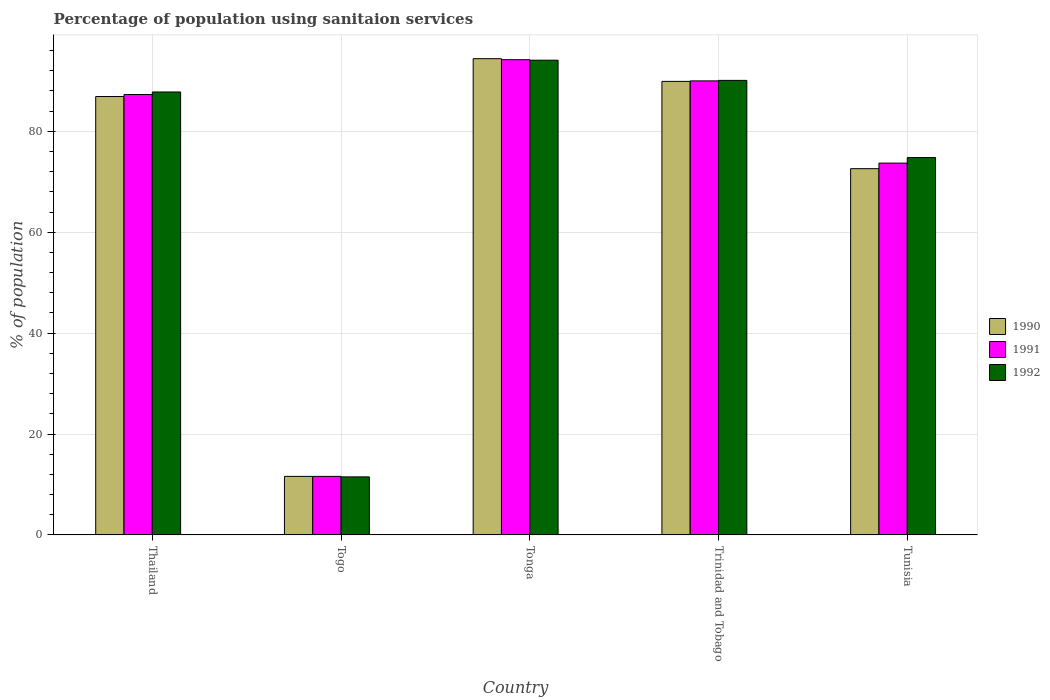How many different coloured bars are there?
Your response must be concise. 3. Are the number of bars on each tick of the X-axis equal?
Keep it short and to the point. Yes. How many bars are there on the 3rd tick from the left?
Offer a terse response. 3. What is the label of the 5th group of bars from the left?
Provide a short and direct response. Tunisia. In how many cases, is the number of bars for a given country not equal to the number of legend labels?
Offer a terse response. 0. What is the percentage of population using sanitaion services in 1992 in Thailand?
Give a very brief answer. 87.8. Across all countries, what is the maximum percentage of population using sanitaion services in 1992?
Keep it short and to the point. 94.1. In which country was the percentage of population using sanitaion services in 1991 maximum?
Offer a terse response. Tonga. In which country was the percentage of population using sanitaion services in 1992 minimum?
Offer a very short reply. Togo. What is the total percentage of population using sanitaion services in 1990 in the graph?
Keep it short and to the point. 355.4. What is the difference between the percentage of population using sanitaion services in 1990 in Togo and that in Trinidad and Tobago?
Provide a short and direct response. -78.3. What is the difference between the percentage of population using sanitaion services in 1992 in Tonga and the percentage of population using sanitaion services in 1990 in Trinidad and Tobago?
Your answer should be compact. 4.2. What is the average percentage of population using sanitaion services in 1991 per country?
Give a very brief answer. 71.36. What is the difference between the percentage of population using sanitaion services of/in 1990 and percentage of population using sanitaion services of/in 1991 in Tonga?
Your answer should be compact. 0.2. In how many countries, is the percentage of population using sanitaion services in 1990 greater than 24 %?
Your response must be concise. 4. What is the ratio of the percentage of population using sanitaion services in 1990 in Thailand to that in Trinidad and Tobago?
Offer a terse response. 0.97. Is the difference between the percentage of population using sanitaion services in 1990 in Thailand and Togo greater than the difference between the percentage of population using sanitaion services in 1991 in Thailand and Togo?
Your response must be concise. No. What is the difference between the highest and the lowest percentage of population using sanitaion services in 1992?
Make the answer very short. 82.6. In how many countries, is the percentage of population using sanitaion services in 1991 greater than the average percentage of population using sanitaion services in 1991 taken over all countries?
Offer a terse response. 4. What does the 1st bar from the left in Togo represents?
Make the answer very short. 1990. Is it the case that in every country, the sum of the percentage of population using sanitaion services in 1992 and percentage of population using sanitaion services in 1990 is greater than the percentage of population using sanitaion services in 1991?
Your answer should be very brief. Yes. How many countries are there in the graph?
Give a very brief answer. 5. What is the difference between two consecutive major ticks on the Y-axis?
Your response must be concise. 20. Does the graph contain any zero values?
Your answer should be compact. No. Where does the legend appear in the graph?
Provide a succinct answer. Center right. How many legend labels are there?
Provide a short and direct response. 3. How are the legend labels stacked?
Your response must be concise. Vertical. What is the title of the graph?
Give a very brief answer. Percentage of population using sanitaion services. What is the label or title of the X-axis?
Provide a short and direct response. Country. What is the label or title of the Y-axis?
Offer a terse response. % of population. What is the % of population of 1990 in Thailand?
Give a very brief answer. 86.9. What is the % of population of 1991 in Thailand?
Ensure brevity in your answer.  87.3. What is the % of population of 1992 in Thailand?
Your answer should be very brief. 87.8. What is the % of population in 1990 in Togo?
Make the answer very short. 11.6. What is the % of population in 1990 in Tonga?
Your response must be concise. 94.4. What is the % of population of 1991 in Tonga?
Keep it short and to the point. 94.2. What is the % of population of 1992 in Tonga?
Your answer should be very brief. 94.1. What is the % of population in 1990 in Trinidad and Tobago?
Keep it short and to the point. 89.9. What is the % of population of 1992 in Trinidad and Tobago?
Offer a terse response. 90.1. What is the % of population of 1990 in Tunisia?
Your answer should be very brief. 72.6. What is the % of population in 1991 in Tunisia?
Provide a succinct answer. 73.7. What is the % of population of 1992 in Tunisia?
Your answer should be very brief. 74.8. Across all countries, what is the maximum % of population in 1990?
Make the answer very short. 94.4. Across all countries, what is the maximum % of population in 1991?
Give a very brief answer. 94.2. Across all countries, what is the maximum % of population of 1992?
Provide a succinct answer. 94.1. Across all countries, what is the minimum % of population in 1990?
Your answer should be compact. 11.6. What is the total % of population in 1990 in the graph?
Ensure brevity in your answer.  355.4. What is the total % of population of 1991 in the graph?
Keep it short and to the point. 356.8. What is the total % of population in 1992 in the graph?
Your answer should be very brief. 358.3. What is the difference between the % of population of 1990 in Thailand and that in Togo?
Provide a short and direct response. 75.3. What is the difference between the % of population in 1991 in Thailand and that in Togo?
Make the answer very short. 75.7. What is the difference between the % of population in 1992 in Thailand and that in Togo?
Provide a succinct answer. 76.3. What is the difference between the % of population in 1991 in Thailand and that in Tonga?
Give a very brief answer. -6.9. What is the difference between the % of population of 1990 in Thailand and that in Trinidad and Tobago?
Provide a short and direct response. -3. What is the difference between the % of population of 1992 in Thailand and that in Trinidad and Tobago?
Provide a short and direct response. -2.3. What is the difference between the % of population in 1991 in Thailand and that in Tunisia?
Ensure brevity in your answer.  13.6. What is the difference between the % of population in 1992 in Thailand and that in Tunisia?
Offer a very short reply. 13. What is the difference between the % of population of 1990 in Togo and that in Tonga?
Keep it short and to the point. -82.8. What is the difference between the % of population in 1991 in Togo and that in Tonga?
Offer a very short reply. -82.6. What is the difference between the % of population in 1992 in Togo and that in Tonga?
Your answer should be compact. -82.6. What is the difference between the % of population in 1990 in Togo and that in Trinidad and Tobago?
Ensure brevity in your answer.  -78.3. What is the difference between the % of population of 1991 in Togo and that in Trinidad and Tobago?
Your answer should be very brief. -78.4. What is the difference between the % of population of 1992 in Togo and that in Trinidad and Tobago?
Ensure brevity in your answer.  -78.6. What is the difference between the % of population in 1990 in Togo and that in Tunisia?
Make the answer very short. -61. What is the difference between the % of population in 1991 in Togo and that in Tunisia?
Make the answer very short. -62.1. What is the difference between the % of population in 1992 in Togo and that in Tunisia?
Provide a succinct answer. -63.3. What is the difference between the % of population of 1990 in Tonga and that in Trinidad and Tobago?
Provide a short and direct response. 4.5. What is the difference between the % of population in 1992 in Tonga and that in Trinidad and Tobago?
Give a very brief answer. 4. What is the difference between the % of population of 1990 in Tonga and that in Tunisia?
Your answer should be compact. 21.8. What is the difference between the % of population of 1992 in Tonga and that in Tunisia?
Your response must be concise. 19.3. What is the difference between the % of population in 1990 in Trinidad and Tobago and that in Tunisia?
Your answer should be very brief. 17.3. What is the difference between the % of population in 1990 in Thailand and the % of population in 1991 in Togo?
Keep it short and to the point. 75.3. What is the difference between the % of population in 1990 in Thailand and the % of population in 1992 in Togo?
Provide a short and direct response. 75.4. What is the difference between the % of population of 1991 in Thailand and the % of population of 1992 in Togo?
Offer a terse response. 75.8. What is the difference between the % of population of 1990 in Thailand and the % of population of 1992 in Trinidad and Tobago?
Your response must be concise. -3.2. What is the difference between the % of population of 1991 in Thailand and the % of population of 1992 in Trinidad and Tobago?
Your answer should be compact. -2.8. What is the difference between the % of population of 1990 in Thailand and the % of population of 1992 in Tunisia?
Your answer should be compact. 12.1. What is the difference between the % of population in 1991 in Thailand and the % of population in 1992 in Tunisia?
Provide a succinct answer. 12.5. What is the difference between the % of population in 1990 in Togo and the % of population in 1991 in Tonga?
Provide a short and direct response. -82.6. What is the difference between the % of population of 1990 in Togo and the % of population of 1992 in Tonga?
Your response must be concise. -82.5. What is the difference between the % of population of 1991 in Togo and the % of population of 1992 in Tonga?
Your answer should be compact. -82.5. What is the difference between the % of population in 1990 in Togo and the % of population in 1991 in Trinidad and Tobago?
Give a very brief answer. -78.4. What is the difference between the % of population in 1990 in Togo and the % of population in 1992 in Trinidad and Tobago?
Provide a succinct answer. -78.5. What is the difference between the % of population in 1991 in Togo and the % of population in 1992 in Trinidad and Tobago?
Make the answer very short. -78.5. What is the difference between the % of population of 1990 in Togo and the % of population of 1991 in Tunisia?
Your response must be concise. -62.1. What is the difference between the % of population of 1990 in Togo and the % of population of 1992 in Tunisia?
Provide a succinct answer. -63.2. What is the difference between the % of population of 1991 in Togo and the % of population of 1992 in Tunisia?
Provide a succinct answer. -63.2. What is the difference between the % of population in 1990 in Tonga and the % of population in 1991 in Trinidad and Tobago?
Offer a terse response. 4.4. What is the difference between the % of population in 1990 in Tonga and the % of population in 1992 in Trinidad and Tobago?
Your answer should be very brief. 4.3. What is the difference between the % of population in 1991 in Tonga and the % of population in 1992 in Trinidad and Tobago?
Offer a very short reply. 4.1. What is the difference between the % of population of 1990 in Tonga and the % of population of 1991 in Tunisia?
Your answer should be very brief. 20.7. What is the difference between the % of population in 1990 in Tonga and the % of population in 1992 in Tunisia?
Provide a short and direct response. 19.6. What is the difference between the % of population in 1991 in Tonga and the % of population in 1992 in Tunisia?
Provide a succinct answer. 19.4. What is the average % of population of 1990 per country?
Your response must be concise. 71.08. What is the average % of population of 1991 per country?
Make the answer very short. 71.36. What is the average % of population of 1992 per country?
Offer a terse response. 71.66. What is the difference between the % of population in 1990 and % of population in 1991 in Thailand?
Keep it short and to the point. -0.4. What is the difference between the % of population of 1991 and % of population of 1992 in Thailand?
Your answer should be compact. -0.5. What is the difference between the % of population in 1990 and % of population in 1991 in Togo?
Your response must be concise. 0. What is the difference between the % of population of 1990 and % of population of 1992 in Togo?
Offer a terse response. 0.1. What is the difference between the % of population in 1990 and % of population in 1991 in Tonga?
Provide a short and direct response. 0.2. What is the difference between the % of population of 1990 and % of population of 1992 in Tonga?
Provide a short and direct response. 0.3. What is the difference between the % of population of 1991 and % of population of 1992 in Tonga?
Provide a short and direct response. 0.1. What is the difference between the % of population in 1990 and % of population in 1991 in Tunisia?
Keep it short and to the point. -1.1. What is the difference between the % of population in 1990 and % of population in 1992 in Tunisia?
Make the answer very short. -2.2. What is the difference between the % of population in 1991 and % of population in 1992 in Tunisia?
Keep it short and to the point. -1.1. What is the ratio of the % of population in 1990 in Thailand to that in Togo?
Provide a succinct answer. 7.49. What is the ratio of the % of population of 1991 in Thailand to that in Togo?
Your answer should be compact. 7.53. What is the ratio of the % of population in 1992 in Thailand to that in Togo?
Provide a succinct answer. 7.63. What is the ratio of the % of population of 1990 in Thailand to that in Tonga?
Give a very brief answer. 0.92. What is the ratio of the % of population of 1991 in Thailand to that in Tonga?
Your answer should be very brief. 0.93. What is the ratio of the % of population of 1992 in Thailand to that in Tonga?
Provide a succinct answer. 0.93. What is the ratio of the % of population of 1990 in Thailand to that in Trinidad and Tobago?
Keep it short and to the point. 0.97. What is the ratio of the % of population of 1992 in Thailand to that in Trinidad and Tobago?
Give a very brief answer. 0.97. What is the ratio of the % of population of 1990 in Thailand to that in Tunisia?
Offer a very short reply. 1.2. What is the ratio of the % of population in 1991 in Thailand to that in Tunisia?
Offer a terse response. 1.18. What is the ratio of the % of population in 1992 in Thailand to that in Tunisia?
Provide a succinct answer. 1.17. What is the ratio of the % of population in 1990 in Togo to that in Tonga?
Provide a succinct answer. 0.12. What is the ratio of the % of population in 1991 in Togo to that in Tonga?
Your response must be concise. 0.12. What is the ratio of the % of population in 1992 in Togo to that in Tonga?
Your response must be concise. 0.12. What is the ratio of the % of population in 1990 in Togo to that in Trinidad and Tobago?
Ensure brevity in your answer.  0.13. What is the ratio of the % of population of 1991 in Togo to that in Trinidad and Tobago?
Your response must be concise. 0.13. What is the ratio of the % of population in 1992 in Togo to that in Trinidad and Tobago?
Make the answer very short. 0.13. What is the ratio of the % of population in 1990 in Togo to that in Tunisia?
Offer a very short reply. 0.16. What is the ratio of the % of population in 1991 in Togo to that in Tunisia?
Offer a very short reply. 0.16. What is the ratio of the % of population in 1992 in Togo to that in Tunisia?
Your answer should be compact. 0.15. What is the ratio of the % of population in 1990 in Tonga to that in Trinidad and Tobago?
Give a very brief answer. 1.05. What is the ratio of the % of population in 1991 in Tonga to that in Trinidad and Tobago?
Offer a terse response. 1.05. What is the ratio of the % of population of 1992 in Tonga to that in Trinidad and Tobago?
Your answer should be compact. 1.04. What is the ratio of the % of population in 1990 in Tonga to that in Tunisia?
Provide a short and direct response. 1.3. What is the ratio of the % of population of 1991 in Tonga to that in Tunisia?
Your answer should be compact. 1.28. What is the ratio of the % of population of 1992 in Tonga to that in Tunisia?
Keep it short and to the point. 1.26. What is the ratio of the % of population of 1990 in Trinidad and Tobago to that in Tunisia?
Ensure brevity in your answer.  1.24. What is the ratio of the % of population in 1991 in Trinidad and Tobago to that in Tunisia?
Your answer should be very brief. 1.22. What is the ratio of the % of population in 1992 in Trinidad and Tobago to that in Tunisia?
Make the answer very short. 1.2. What is the difference between the highest and the second highest % of population of 1990?
Provide a succinct answer. 4.5. What is the difference between the highest and the second highest % of population in 1992?
Your response must be concise. 4. What is the difference between the highest and the lowest % of population in 1990?
Ensure brevity in your answer.  82.8. What is the difference between the highest and the lowest % of population in 1991?
Provide a short and direct response. 82.6. What is the difference between the highest and the lowest % of population of 1992?
Give a very brief answer. 82.6. 